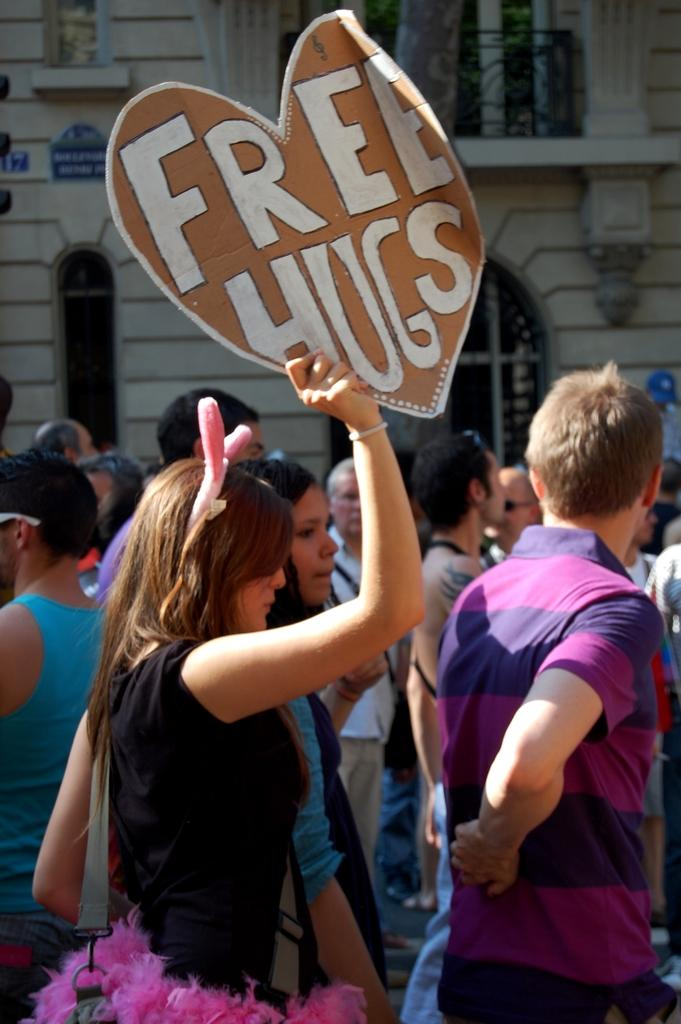How many people are in the image? There is a group of people in the image, but the exact number cannot be determined from the provided facts. What is the woman in the image doing? The woman is holding a banner in the image. What can be seen in the background of the image? There is a building with windows in the background of the image. What type of key is the moon using to unlock the door in the image? There is no moon or door present in the image, so it is not possible to answer that question. 